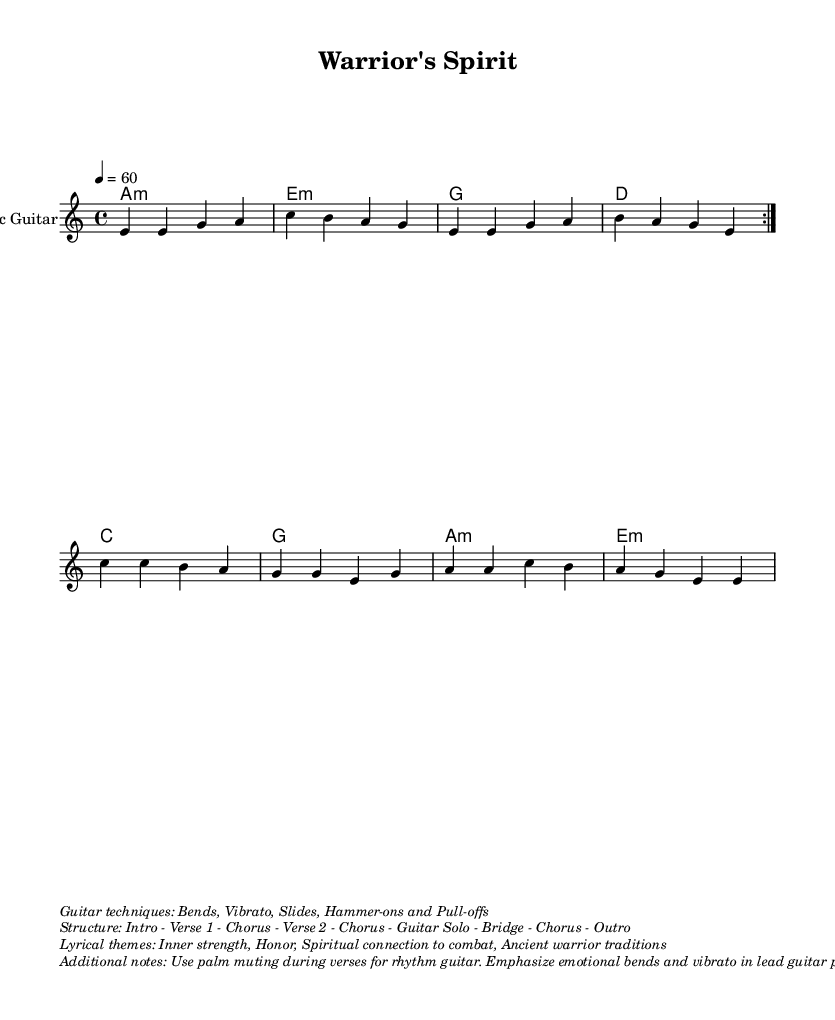What is the key signature of this music? The key signature is identified by the placement of sharps or flats at the beginning of the staff. In this case, the absence of any sharps or flats indicates that the key is A minor, which is the relative minor of C major.
Answer: A minor What is the time signature of this piece? The time signature is indicated by the fraction at the beginning of the score, showing the number of beats in a measure and the note value that gets one beat. Here, 4/4 means there are four beats per measure, with the quarter note receiving one beat.
Answer: 4/4 What is the tempo marking for this piece? The tempo is indicated at the beginning of the music with a numerical value followed by a type of note. "4 = 60" indicates that a quarter note should be played at a speed of 60 beats per minute.
Answer: 60 How many times is the guitar verse repeated in the structure? The structure of the piece indicates that the guitar verse is marked with "\repeat volta 2", which means it should be played two times before moving on to the chorus.
Answer: 2 What techniques are emphasized in the guitar parts? The markup at the end of the score describes the techniques to be used in the guitar parts. Terms like "Bends, Vibrato, Slides, Hammer-ons and Pull-offs" are specifically mentioned as the techniques to emphasize during play.
Answer: Bends, Vibrato, Slides, Hammer-ons and Pull-offs What is the main lyrical theme of this piece? The lyrical theme is noted in the markup section, which lists "Inner strength, Honor, Spiritual connection to combat, Ancient warrior traditions" as the key themes explored in the lyrics.
Answer: Inner strength, Honor, Spiritual connection to combat, Ancient warrior traditions 